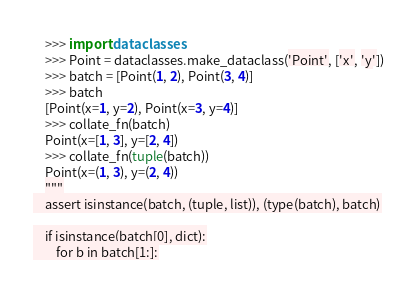<code> <loc_0><loc_0><loc_500><loc_500><_Python_>    >>> import dataclasses
    >>> Point = dataclasses.make_dataclass('Point', ['x', 'y'])
    >>> batch = [Point(1, 2), Point(3, 4)]
    >>> batch
    [Point(x=1, y=2), Point(x=3, y=4)]
    >>> collate_fn(batch)
    Point(x=[1, 3], y=[2, 4])
    >>> collate_fn(tuple(batch))
    Point(x=(1, 3), y=(2, 4))
    """
    assert isinstance(batch, (tuple, list)), (type(batch), batch)

    if isinstance(batch[0], dict):
        for b in batch[1:]:</code> 